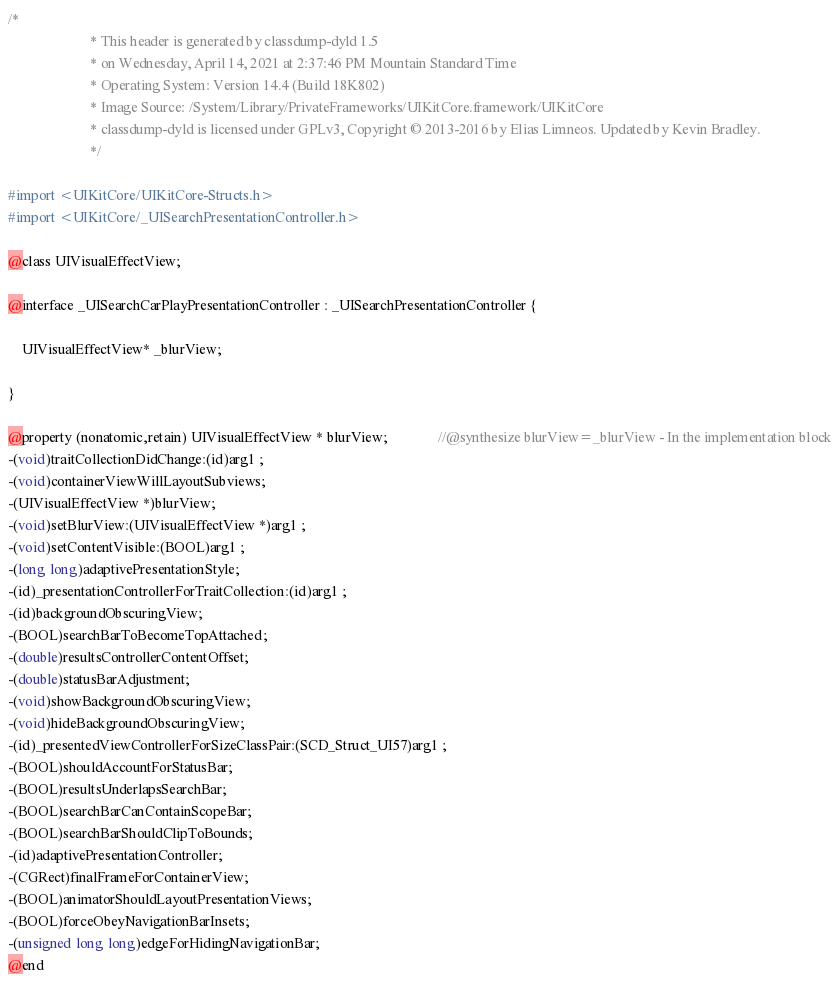<code> <loc_0><loc_0><loc_500><loc_500><_C_>/*
                       * This header is generated by classdump-dyld 1.5
                       * on Wednesday, April 14, 2021 at 2:37:46 PM Mountain Standard Time
                       * Operating System: Version 14.4 (Build 18K802)
                       * Image Source: /System/Library/PrivateFrameworks/UIKitCore.framework/UIKitCore
                       * classdump-dyld is licensed under GPLv3, Copyright © 2013-2016 by Elias Limneos. Updated by Kevin Bradley.
                       */

#import <UIKitCore/UIKitCore-Structs.h>
#import <UIKitCore/_UISearchPresentationController.h>

@class UIVisualEffectView;

@interface _UISearchCarPlayPresentationController : _UISearchPresentationController {

	UIVisualEffectView* _blurView;

}

@property (nonatomic,retain) UIVisualEffectView * blurView;              //@synthesize blurView=_blurView - In the implementation block
-(void)traitCollectionDidChange:(id)arg1 ;
-(void)containerViewWillLayoutSubviews;
-(UIVisualEffectView *)blurView;
-(void)setBlurView:(UIVisualEffectView *)arg1 ;
-(void)setContentVisible:(BOOL)arg1 ;
-(long long)adaptivePresentationStyle;
-(id)_presentationControllerForTraitCollection:(id)arg1 ;
-(id)backgroundObscuringView;
-(BOOL)searchBarToBecomeTopAttached;
-(double)resultsControllerContentOffset;
-(double)statusBarAdjustment;
-(void)showBackgroundObscuringView;
-(void)hideBackgroundObscuringView;
-(id)_presentedViewControllerForSizeClassPair:(SCD_Struct_UI57)arg1 ;
-(BOOL)shouldAccountForStatusBar;
-(BOOL)resultsUnderlapsSearchBar;
-(BOOL)searchBarCanContainScopeBar;
-(BOOL)searchBarShouldClipToBounds;
-(id)adaptivePresentationController;
-(CGRect)finalFrameForContainerView;
-(BOOL)animatorShouldLayoutPresentationViews;
-(BOOL)forceObeyNavigationBarInsets;
-(unsigned long long)edgeForHidingNavigationBar;
@end

</code> 